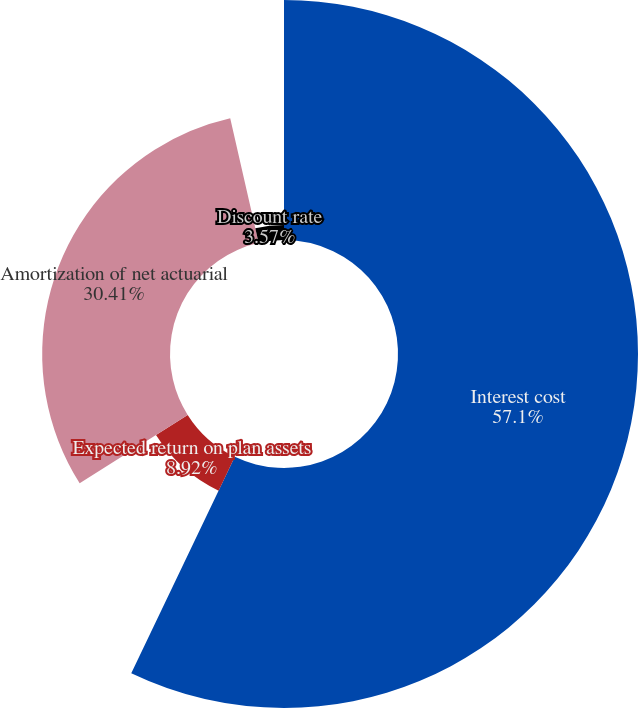Convert chart to OTSL. <chart><loc_0><loc_0><loc_500><loc_500><pie_chart><fcel>Interest cost<fcel>Expected return on plan assets<fcel>Amortization of net actuarial<fcel>Discount rate<nl><fcel>57.1%<fcel>8.92%<fcel>30.41%<fcel>3.57%<nl></chart> 